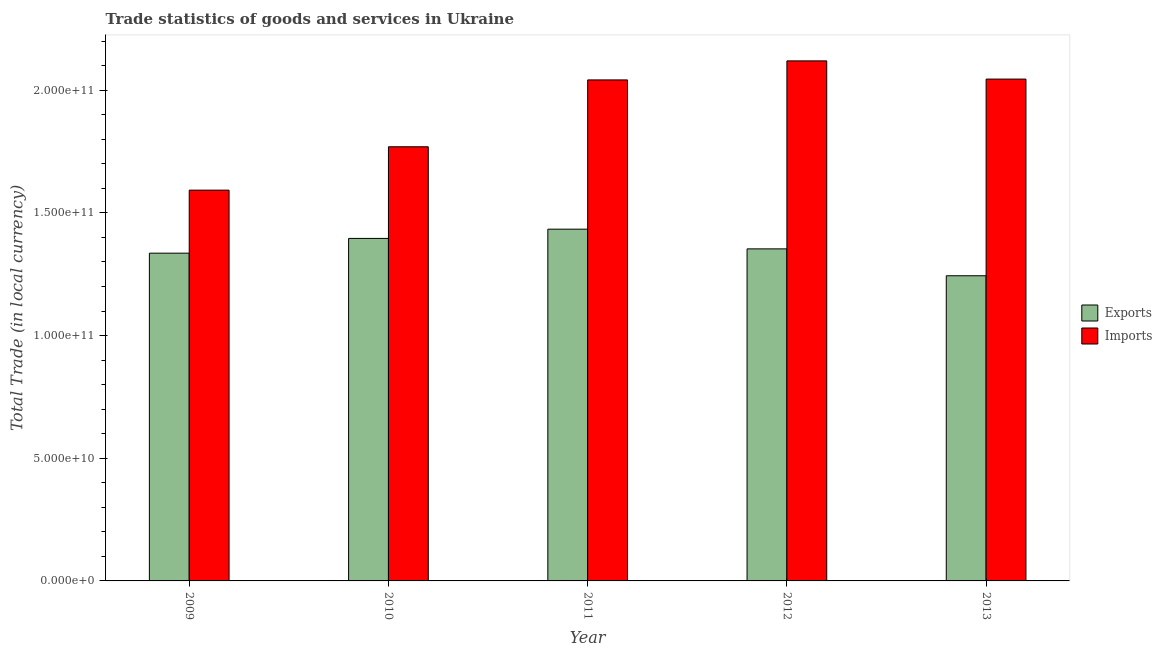How many different coloured bars are there?
Offer a very short reply. 2. How many groups of bars are there?
Your answer should be very brief. 5. Are the number of bars per tick equal to the number of legend labels?
Make the answer very short. Yes. How many bars are there on the 5th tick from the left?
Make the answer very short. 2. What is the imports of goods and services in 2009?
Your answer should be compact. 1.59e+11. Across all years, what is the maximum export of goods and services?
Make the answer very short. 1.43e+11. Across all years, what is the minimum export of goods and services?
Offer a terse response. 1.24e+11. In which year was the imports of goods and services maximum?
Your response must be concise. 2012. What is the total export of goods and services in the graph?
Your answer should be very brief. 6.76e+11. What is the difference between the export of goods and services in 2010 and that in 2012?
Ensure brevity in your answer.  4.26e+09. What is the difference between the export of goods and services in 2011 and the imports of goods and services in 2013?
Keep it short and to the point. 1.90e+1. What is the average imports of goods and services per year?
Provide a short and direct response. 1.91e+11. What is the ratio of the export of goods and services in 2012 to that in 2013?
Make the answer very short. 1.09. Is the export of goods and services in 2010 less than that in 2012?
Make the answer very short. No. What is the difference between the highest and the second highest export of goods and services?
Offer a very short reply. 3.77e+09. What is the difference between the highest and the lowest imports of goods and services?
Offer a terse response. 5.27e+1. In how many years, is the imports of goods and services greater than the average imports of goods and services taken over all years?
Make the answer very short. 3. Is the sum of the imports of goods and services in 2009 and 2012 greater than the maximum export of goods and services across all years?
Make the answer very short. Yes. What does the 2nd bar from the left in 2012 represents?
Provide a short and direct response. Imports. What does the 1st bar from the right in 2012 represents?
Provide a short and direct response. Imports. How many bars are there?
Give a very brief answer. 10. How many years are there in the graph?
Your answer should be very brief. 5. Are the values on the major ticks of Y-axis written in scientific E-notation?
Ensure brevity in your answer.  Yes. Where does the legend appear in the graph?
Give a very brief answer. Center right. How many legend labels are there?
Your response must be concise. 2. How are the legend labels stacked?
Your answer should be compact. Vertical. What is the title of the graph?
Your answer should be very brief. Trade statistics of goods and services in Ukraine. Does "Total Population" appear as one of the legend labels in the graph?
Your answer should be compact. No. What is the label or title of the Y-axis?
Keep it short and to the point. Total Trade (in local currency). What is the Total Trade (in local currency) of Exports in 2009?
Make the answer very short. 1.34e+11. What is the Total Trade (in local currency) of Imports in 2009?
Ensure brevity in your answer.  1.59e+11. What is the Total Trade (in local currency) of Exports in 2010?
Give a very brief answer. 1.40e+11. What is the Total Trade (in local currency) of Imports in 2010?
Give a very brief answer. 1.77e+11. What is the Total Trade (in local currency) of Exports in 2011?
Offer a very short reply. 1.43e+11. What is the Total Trade (in local currency) of Imports in 2011?
Your response must be concise. 2.04e+11. What is the Total Trade (in local currency) of Exports in 2012?
Keep it short and to the point. 1.35e+11. What is the Total Trade (in local currency) in Imports in 2012?
Provide a short and direct response. 2.12e+11. What is the Total Trade (in local currency) in Exports in 2013?
Your response must be concise. 1.24e+11. What is the Total Trade (in local currency) in Imports in 2013?
Make the answer very short. 2.05e+11. Across all years, what is the maximum Total Trade (in local currency) in Exports?
Offer a terse response. 1.43e+11. Across all years, what is the maximum Total Trade (in local currency) in Imports?
Keep it short and to the point. 2.12e+11. Across all years, what is the minimum Total Trade (in local currency) in Exports?
Your response must be concise. 1.24e+11. Across all years, what is the minimum Total Trade (in local currency) in Imports?
Keep it short and to the point. 1.59e+11. What is the total Total Trade (in local currency) in Exports in the graph?
Your answer should be compact. 6.76e+11. What is the total Total Trade (in local currency) of Imports in the graph?
Provide a succinct answer. 9.57e+11. What is the difference between the Total Trade (in local currency) in Exports in 2009 and that in 2010?
Give a very brief answer. -6.01e+09. What is the difference between the Total Trade (in local currency) of Imports in 2009 and that in 2010?
Give a very brief answer. -1.77e+1. What is the difference between the Total Trade (in local currency) in Exports in 2009 and that in 2011?
Provide a succinct answer. -9.78e+09. What is the difference between the Total Trade (in local currency) of Imports in 2009 and that in 2011?
Give a very brief answer. -4.49e+1. What is the difference between the Total Trade (in local currency) of Exports in 2009 and that in 2012?
Offer a terse response. -1.75e+09. What is the difference between the Total Trade (in local currency) in Imports in 2009 and that in 2012?
Ensure brevity in your answer.  -5.27e+1. What is the difference between the Total Trade (in local currency) of Exports in 2009 and that in 2013?
Provide a succinct answer. 9.21e+09. What is the difference between the Total Trade (in local currency) of Imports in 2009 and that in 2013?
Your answer should be compact. -4.53e+1. What is the difference between the Total Trade (in local currency) of Exports in 2010 and that in 2011?
Give a very brief answer. -3.77e+09. What is the difference between the Total Trade (in local currency) of Imports in 2010 and that in 2011?
Ensure brevity in your answer.  -2.72e+1. What is the difference between the Total Trade (in local currency) of Exports in 2010 and that in 2012?
Your answer should be compact. 4.26e+09. What is the difference between the Total Trade (in local currency) in Imports in 2010 and that in 2012?
Keep it short and to the point. -3.50e+1. What is the difference between the Total Trade (in local currency) in Exports in 2010 and that in 2013?
Your answer should be compact. 1.52e+1. What is the difference between the Total Trade (in local currency) of Imports in 2010 and that in 2013?
Make the answer very short. -2.76e+1. What is the difference between the Total Trade (in local currency) of Exports in 2011 and that in 2012?
Keep it short and to the point. 8.03e+09. What is the difference between the Total Trade (in local currency) of Imports in 2011 and that in 2012?
Offer a very short reply. -7.76e+09. What is the difference between the Total Trade (in local currency) of Exports in 2011 and that in 2013?
Offer a very short reply. 1.90e+1. What is the difference between the Total Trade (in local currency) in Imports in 2011 and that in 2013?
Give a very brief answer. -3.41e+08. What is the difference between the Total Trade (in local currency) of Exports in 2012 and that in 2013?
Your answer should be very brief. 1.10e+1. What is the difference between the Total Trade (in local currency) in Imports in 2012 and that in 2013?
Offer a terse response. 7.42e+09. What is the difference between the Total Trade (in local currency) in Exports in 2009 and the Total Trade (in local currency) in Imports in 2010?
Provide a succinct answer. -4.34e+1. What is the difference between the Total Trade (in local currency) in Exports in 2009 and the Total Trade (in local currency) in Imports in 2011?
Ensure brevity in your answer.  -7.06e+1. What is the difference between the Total Trade (in local currency) of Exports in 2009 and the Total Trade (in local currency) of Imports in 2012?
Provide a succinct answer. -7.84e+1. What is the difference between the Total Trade (in local currency) in Exports in 2009 and the Total Trade (in local currency) in Imports in 2013?
Give a very brief answer. -7.09e+1. What is the difference between the Total Trade (in local currency) in Exports in 2010 and the Total Trade (in local currency) in Imports in 2011?
Your answer should be very brief. -6.46e+1. What is the difference between the Total Trade (in local currency) in Exports in 2010 and the Total Trade (in local currency) in Imports in 2012?
Your answer should be compact. -7.24e+1. What is the difference between the Total Trade (in local currency) of Exports in 2010 and the Total Trade (in local currency) of Imports in 2013?
Provide a short and direct response. -6.49e+1. What is the difference between the Total Trade (in local currency) of Exports in 2011 and the Total Trade (in local currency) of Imports in 2012?
Provide a short and direct response. -6.86e+1. What is the difference between the Total Trade (in local currency) in Exports in 2011 and the Total Trade (in local currency) in Imports in 2013?
Make the answer very short. -6.12e+1. What is the difference between the Total Trade (in local currency) in Exports in 2012 and the Total Trade (in local currency) in Imports in 2013?
Your response must be concise. -6.92e+1. What is the average Total Trade (in local currency) of Exports per year?
Give a very brief answer. 1.35e+11. What is the average Total Trade (in local currency) in Imports per year?
Ensure brevity in your answer.  1.91e+11. In the year 2009, what is the difference between the Total Trade (in local currency) of Exports and Total Trade (in local currency) of Imports?
Offer a very short reply. -2.57e+1. In the year 2010, what is the difference between the Total Trade (in local currency) in Exports and Total Trade (in local currency) in Imports?
Ensure brevity in your answer.  -3.73e+1. In the year 2011, what is the difference between the Total Trade (in local currency) of Exports and Total Trade (in local currency) of Imports?
Your response must be concise. -6.08e+1. In the year 2012, what is the difference between the Total Trade (in local currency) of Exports and Total Trade (in local currency) of Imports?
Your response must be concise. -7.66e+1. In the year 2013, what is the difference between the Total Trade (in local currency) in Exports and Total Trade (in local currency) in Imports?
Provide a short and direct response. -8.02e+1. What is the ratio of the Total Trade (in local currency) of Exports in 2009 to that in 2010?
Offer a very short reply. 0.96. What is the ratio of the Total Trade (in local currency) in Imports in 2009 to that in 2010?
Offer a terse response. 0.9. What is the ratio of the Total Trade (in local currency) in Exports in 2009 to that in 2011?
Your answer should be very brief. 0.93. What is the ratio of the Total Trade (in local currency) in Imports in 2009 to that in 2011?
Offer a terse response. 0.78. What is the ratio of the Total Trade (in local currency) in Exports in 2009 to that in 2012?
Your answer should be very brief. 0.99. What is the ratio of the Total Trade (in local currency) of Imports in 2009 to that in 2012?
Make the answer very short. 0.75. What is the ratio of the Total Trade (in local currency) in Exports in 2009 to that in 2013?
Provide a succinct answer. 1.07. What is the ratio of the Total Trade (in local currency) in Imports in 2009 to that in 2013?
Offer a very short reply. 0.78. What is the ratio of the Total Trade (in local currency) in Exports in 2010 to that in 2011?
Your answer should be compact. 0.97. What is the ratio of the Total Trade (in local currency) of Imports in 2010 to that in 2011?
Your response must be concise. 0.87. What is the ratio of the Total Trade (in local currency) in Exports in 2010 to that in 2012?
Provide a succinct answer. 1.03. What is the ratio of the Total Trade (in local currency) in Imports in 2010 to that in 2012?
Give a very brief answer. 0.83. What is the ratio of the Total Trade (in local currency) in Exports in 2010 to that in 2013?
Your answer should be compact. 1.12. What is the ratio of the Total Trade (in local currency) in Imports in 2010 to that in 2013?
Provide a short and direct response. 0.87. What is the ratio of the Total Trade (in local currency) of Exports in 2011 to that in 2012?
Your answer should be compact. 1.06. What is the ratio of the Total Trade (in local currency) in Imports in 2011 to that in 2012?
Ensure brevity in your answer.  0.96. What is the ratio of the Total Trade (in local currency) in Exports in 2011 to that in 2013?
Provide a succinct answer. 1.15. What is the ratio of the Total Trade (in local currency) in Exports in 2012 to that in 2013?
Provide a succinct answer. 1.09. What is the ratio of the Total Trade (in local currency) of Imports in 2012 to that in 2013?
Ensure brevity in your answer.  1.04. What is the difference between the highest and the second highest Total Trade (in local currency) in Exports?
Offer a terse response. 3.77e+09. What is the difference between the highest and the second highest Total Trade (in local currency) of Imports?
Your response must be concise. 7.42e+09. What is the difference between the highest and the lowest Total Trade (in local currency) in Exports?
Provide a short and direct response. 1.90e+1. What is the difference between the highest and the lowest Total Trade (in local currency) of Imports?
Your answer should be very brief. 5.27e+1. 